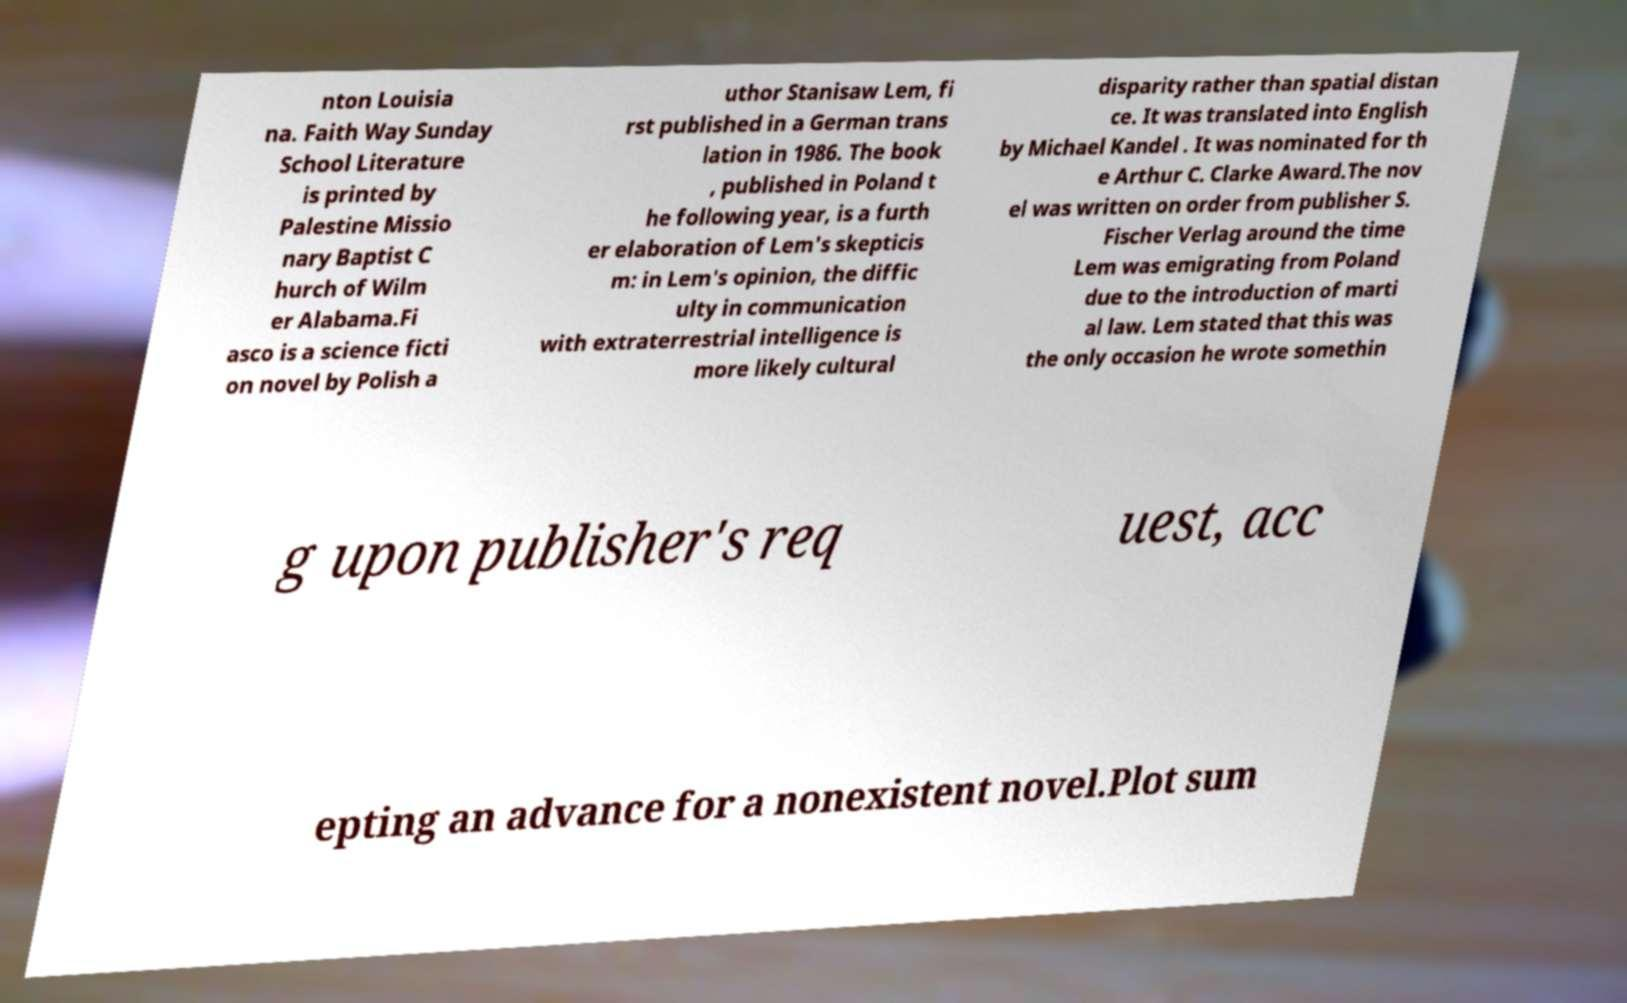I need the written content from this picture converted into text. Can you do that? nton Louisia na. Faith Way Sunday School Literature is printed by Palestine Missio nary Baptist C hurch of Wilm er Alabama.Fi asco is a science ficti on novel by Polish a uthor Stanisaw Lem, fi rst published in a German trans lation in 1986. The book , published in Poland t he following year, is a furth er elaboration of Lem's skepticis m: in Lem's opinion, the diffic ulty in communication with extraterrestrial intelligence is more likely cultural disparity rather than spatial distan ce. It was translated into English by Michael Kandel . It was nominated for th e Arthur C. Clarke Award.The nov el was written on order from publisher S. Fischer Verlag around the time Lem was emigrating from Poland due to the introduction of marti al law. Lem stated that this was the only occasion he wrote somethin g upon publisher's req uest, acc epting an advance for a nonexistent novel.Plot sum 